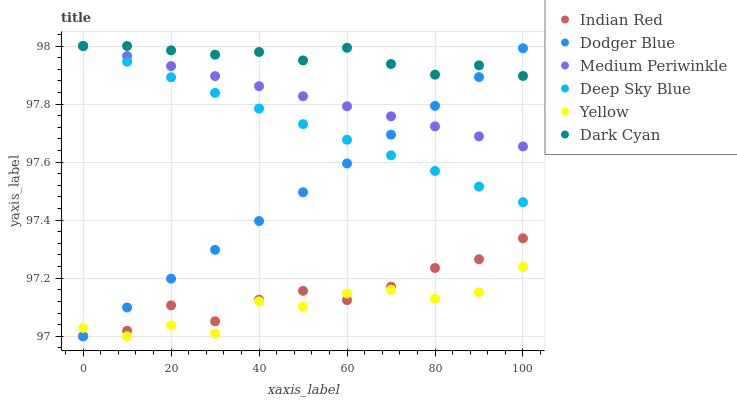Does Yellow have the minimum area under the curve?
Answer yes or no. Yes. Does Dark Cyan have the maximum area under the curve?
Answer yes or no. Yes. Does Medium Periwinkle have the minimum area under the curve?
Answer yes or no. No. Does Medium Periwinkle have the maximum area under the curve?
Answer yes or no. No. Is Deep Sky Blue the smoothest?
Answer yes or no. Yes. Is Yellow the roughest?
Answer yes or no. Yes. Is Medium Periwinkle the smoothest?
Answer yes or no. No. Is Medium Periwinkle the roughest?
Answer yes or no. No. Does Indian Red have the lowest value?
Answer yes or no. Yes. Does Medium Periwinkle have the lowest value?
Answer yes or no. No. Does Dark Cyan have the highest value?
Answer yes or no. Yes. Does Yellow have the highest value?
Answer yes or no. No. Is Yellow less than Dark Cyan?
Answer yes or no. Yes. Is Deep Sky Blue greater than Yellow?
Answer yes or no. Yes. Does Deep Sky Blue intersect Dodger Blue?
Answer yes or no. Yes. Is Deep Sky Blue less than Dodger Blue?
Answer yes or no. No. Is Deep Sky Blue greater than Dodger Blue?
Answer yes or no. No. Does Yellow intersect Dark Cyan?
Answer yes or no. No. 